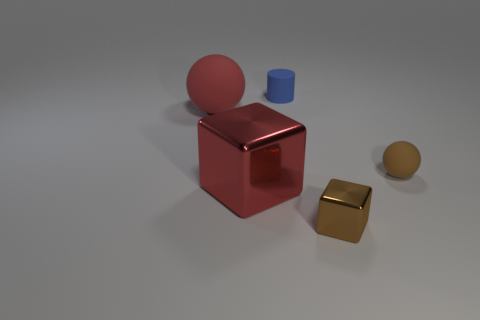What materials do the objects in the image seem to be made of? The objects appear to be rendered with materials imitating metal and plastic. The sphere and the cube on the right have reflective surfaces suggesting a metallic nature, while the blue cylinder looks like it could be made of a matte plastic. 